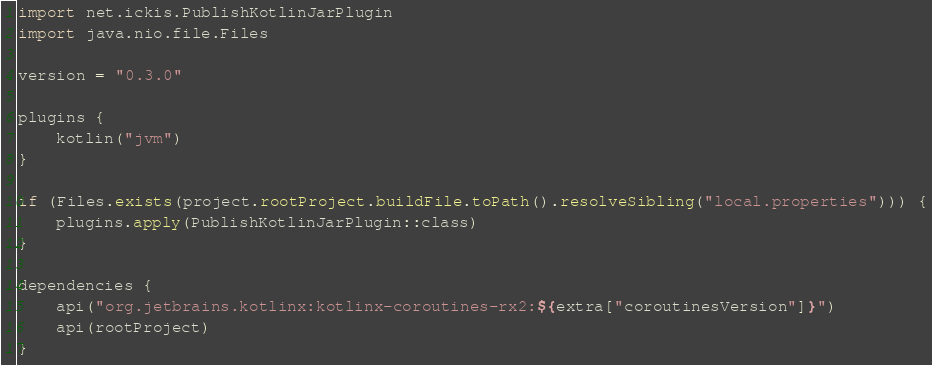Convert code to text. <code><loc_0><loc_0><loc_500><loc_500><_Kotlin_>import net.ickis.PublishKotlinJarPlugin
import java.nio.file.Files

version = "0.3.0"

plugins {
    kotlin("jvm")
}

if (Files.exists(project.rootProject.buildFile.toPath().resolveSibling("local.properties"))) {
    plugins.apply(PublishKotlinJarPlugin::class)
}

dependencies {
    api("org.jetbrains.kotlinx:kotlinx-coroutines-rx2:${extra["coroutinesVersion"]}")
    api(rootProject)
}
</code> 